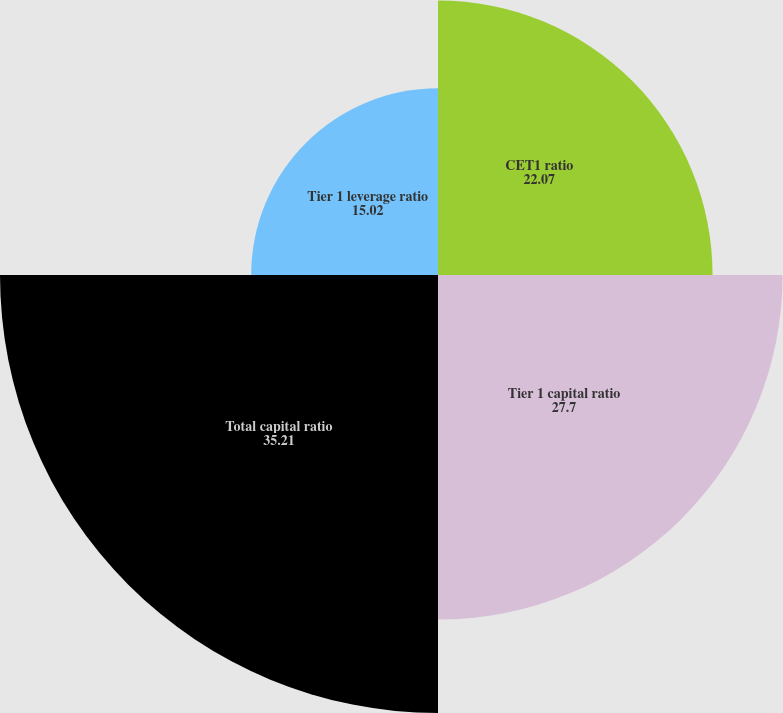Convert chart. <chart><loc_0><loc_0><loc_500><loc_500><pie_chart><fcel>CET1 ratio<fcel>Tier 1 capital ratio<fcel>Total capital ratio<fcel>Tier 1 leverage ratio<nl><fcel>22.07%<fcel>27.7%<fcel>35.21%<fcel>15.02%<nl></chart> 